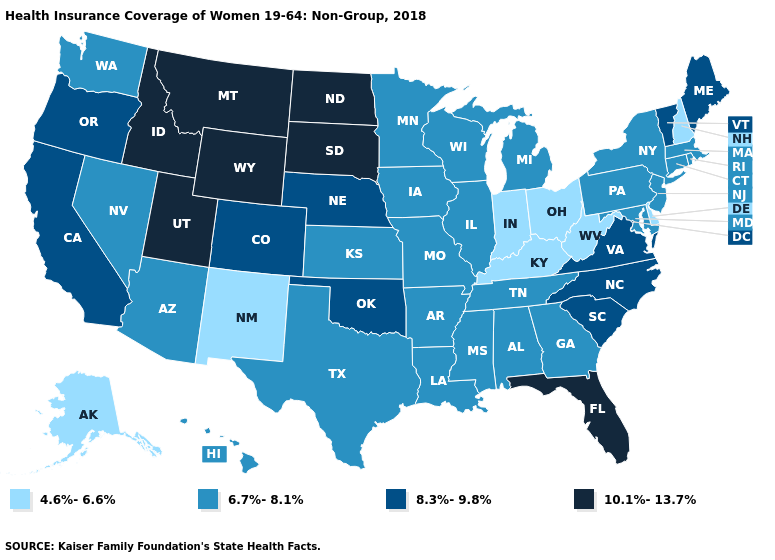Is the legend a continuous bar?
Concise answer only. No. Name the states that have a value in the range 10.1%-13.7%?
Quick response, please. Florida, Idaho, Montana, North Dakota, South Dakota, Utah, Wyoming. What is the lowest value in the USA?
Concise answer only. 4.6%-6.6%. Name the states that have a value in the range 4.6%-6.6%?
Be succinct. Alaska, Delaware, Indiana, Kentucky, New Hampshire, New Mexico, Ohio, West Virginia. What is the value of Delaware?
Answer briefly. 4.6%-6.6%. What is the highest value in the USA?
Answer briefly. 10.1%-13.7%. Name the states that have a value in the range 6.7%-8.1%?
Short answer required. Alabama, Arizona, Arkansas, Connecticut, Georgia, Hawaii, Illinois, Iowa, Kansas, Louisiana, Maryland, Massachusetts, Michigan, Minnesota, Mississippi, Missouri, Nevada, New Jersey, New York, Pennsylvania, Rhode Island, Tennessee, Texas, Washington, Wisconsin. What is the value of Montana?
Quick response, please. 10.1%-13.7%. What is the lowest value in the MidWest?
Give a very brief answer. 4.6%-6.6%. What is the value of Louisiana?
Short answer required. 6.7%-8.1%. What is the value of Montana?
Write a very short answer. 10.1%-13.7%. What is the lowest value in the Northeast?
Keep it brief. 4.6%-6.6%. What is the value of West Virginia?
Be succinct. 4.6%-6.6%. Name the states that have a value in the range 6.7%-8.1%?
Short answer required. Alabama, Arizona, Arkansas, Connecticut, Georgia, Hawaii, Illinois, Iowa, Kansas, Louisiana, Maryland, Massachusetts, Michigan, Minnesota, Mississippi, Missouri, Nevada, New Jersey, New York, Pennsylvania, Rhode Island, Tennessee, Texas, Washington, Wisconsin. What is the value of Michigan?
Keep it brief. 6.7%-8.1%. 